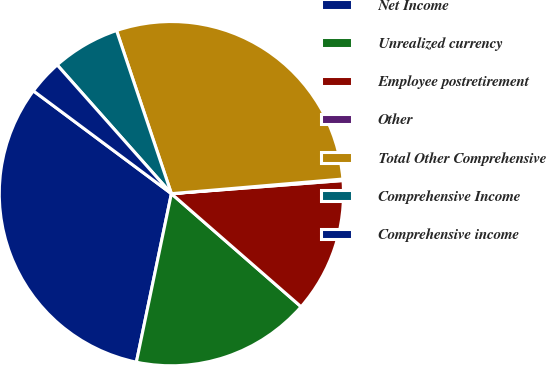Convert chart. <chart><loc_0><loc_0><loc_500><loc_500><pie_chart><fcel>Net Income<fcel>Unrealized currency<fcel>Employee postretirement<fcel>Other<fcel>Total Other Comprehensive<fcel>Comprehensive Income<fcel>Comprehensive income<nl><fcel>31.93%<fcel>16.85%<fcel>12.63%<fcel>0.14%<fcel>28.81%<fcel>6.39%<fcel>3.26%<nl></chart> 